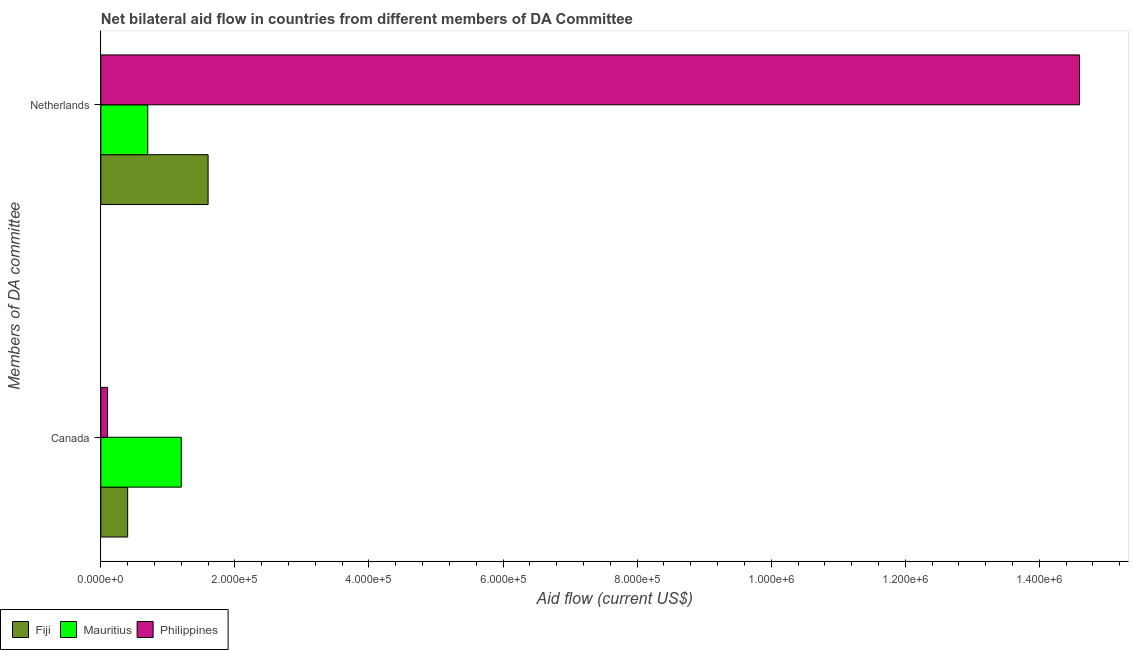How many groups of bars are there?
Your answer should be very brief. 2. Are the number of bars per tick equal to the number of legend labels?
Provide a short and direct response. Yes. How many bars are there on the 2nd tick from the top?
Provide a succinct answer. 3. What is the label of the 1st group of bars from the top?
Your response must be concise. Netherlands. What is the amount of aid given by netherlands in Fiji?
Offer a very short reply. 1.60e+05. Across all countries, what is the maximum amount of aid given by canada?
Provide a short and direct response. 1.20e+05. Across all countries, what is the minimum amount of aid given by canada?
Make the answer very short. 10000. In which country was the amount of aid given by canada minimum?
Provide a short and direct response. Philippines. What is the total amount of aid given by canada in the graph?
Keep it short and to the point. 1.70e+05. What is the difference between the amount of aid given by netherlands in Philippines and that in Fiji?
Make the answer very short. 1.30e+06. What is the difference between the amount of aid given by netherlands in Mauritius and the amount of aid given by canada in Philippines?
Provide a succinct answer. 6.00e+04. What is the average amount of aid given by canada per country?
Offer a very short reply. 5.67e+04. What is the difference between the amount of aid given by canada and amount of aid given by netherlands in Philippines?
Provide a succinct answer. -1.45e+06. In how many countries, is the amount of aid given by canada greater than 40000 US$?
Your response must be concise. 1. What is the ratio of the amount of aid given by canada in Philippines to that in Mauritius?
Your answer should be very brief. 0.08. Is the amount of aid given by netherlands in Mauritius less than that in Fiji?
Ensure brevity in your answer.  Yes. What does the 2nd bar from the top in Canada represents?
Ensure brevity in your answer.  Mauritius. What does the 1st bar from the bottom in Netherlands represents?
Offer a terse response. Fiji. Are all the bars in the graph horizontal?
Offer a terse response. Yes. How many countries are there in the graph?
Ensure brevity in your answer.  3. What is the difference between two consecutive major ticks on the X-axis?
Provide a short and direct response. 2.00e+05. Are the values on the major ticks of X-axis written in scientific E-notation?
Keep it short and to the point. Yes. Does the graph contain any zero values?
Your answer should be very brief. No. Does the graph contain grids?
Your response must be concise. No. Where does the legend appear in the graph?
Provide a succinct answer. Bottom left. How many legend labels are there?
Give a very brief answer. 3. How are the legend labels stacked?
Provide a short and direct response. Horizontal. What is the title of the graph?
Offer a terse response. Net bilateral aid flow in countries from different members of DA Committee. Does "Sao Tome and Principe" appear as one of the legend labels in the graph?
Ensure brevity in your answer.  No. What is the label or title of the Y-axis?
Keep it short and to the point. Members of DA committee. What is the Aid flow (current US$) in Mauritius in Netherlands?
Your answer should be compact. 7.00e+04. What is the Aid flow (current US$) of Philippines in Netherlands?
Make the answer very short. 1.46e+06. Across all Members of DA committee, what is the maximum Aid flow (current US$) of Fiji?
Provide a short and direct response. 1.60e+05. Across all Members of DA committee, what is the maximum Aid flow (current US$) in Mauritius?
Make the answer very short. 1.20e+05. Across all Members of DA committee, what is the maximum Aid flow (current US$) of Philippines?
Offer a terse response. 1.46e+06. Across all Members of DA committee, what is the minimum Aid flow (current US$) in Philippines?
Offer a terse response. 10000. What is the total Aid flow (current US$) of Fiji in the graph?
Your answer should be compact. 2.00e+05. What is the total Aid flow (current US$) in Mauritius in the graph?
Make the answer very short. 1.90e+05. What is the total Aid flow (current US$) in Philippines in the graph?
Keep it short and to the point. 1.47e+06. What is the difference between the Aid flow (current US$) of Fiji in Canada and that in Netherlands?
Provide a short and direct response. -1.20e+05. What is the difference between the Aid flow (current US$) in Philippines in Canada and that in Netherlands?
Keep it short and to the point. -1.45e+06. What is the difference between the Aid flow (current US$) of Fiji in Canada and the Aid flow (current US$) of Mauritius in Netherlands?
Give a very brief answer. -3.00e+04. What is the difference between the Aid flow (current US$) of Fiji in Canada and the Aid flow (current US$) of Philippines in Netherlands?
Provide a short and direct response. -1.42e+06. What is the difference between the Aid flow (current US$) of Mauritius in Canada and the Aid flow (current US$) of Philippines in Netherlands?
Your answer should be very brief. -1.34e+06. What is the average Aid flow (current US$) of Fiji per Members of DA committee?
Give a very brief answer. 1.00e+05. What is the average Aid flow (current US$) of Mauritius per Members of DA committee?
Offer a terse response. 9.50e+04. What is the average Aid flow (current US$) of Philippines per Members of DA committee?
Provide a short and direct response. 7.35e+05. What is the difference between the Aid flow (current US$) of Fiji and Aid flow (current US$) of Mauritius in Canada?
Ensure brevity in your answer.  -8.00e+04. What is the difference between the Aid flow (current US$) in Mauritius and Aid flow (current US$) in Philippines in Canada?
Your response must be concise. 1.10e+05. What is the difference between the Aid flow (current US$) in Fiji and Aid flow (current US$) in Philippines in Netherlands?
Make the answer very short. -1.30e+06. What is the difference between the Aid flow (current US$) of Mauritius and Aid flow (current US$) of Philippines in Netherlands?
Make the answer very short. -1.39e+06. What is the ratio of the Aid flow (current US$) of Mauritius in Canada to that in Netherlands?
Give a very brief answer. 1.71. What is the ratio of the Aid flow (current US$) of Philippines in Canada to that in Netherlands?
Give a very brief answer. 0.01. What is the difference between the highest and the second highest Aid flow (current US$) of Fiji?
Give a very brief answer. 1.20e+05. What is the difference between the highest and the second highest Aid flow (current US$) of Mauritius?
Ensure brevity in your answer.  5.00e+04. What is the difference between the highest and the second highest Aid flow (current US$) in Philippines?
Your answer should be very brief. 1.45e+06. What is the difference between the highest and the lowest Aid flow (current US$) of Mauritius?
Provide a succinct answer. 5.00e+04. What is the difference between the highest and the lowest Aid flow (current US$) in Philippines?
Your response must be concise. 1.45e+06. 